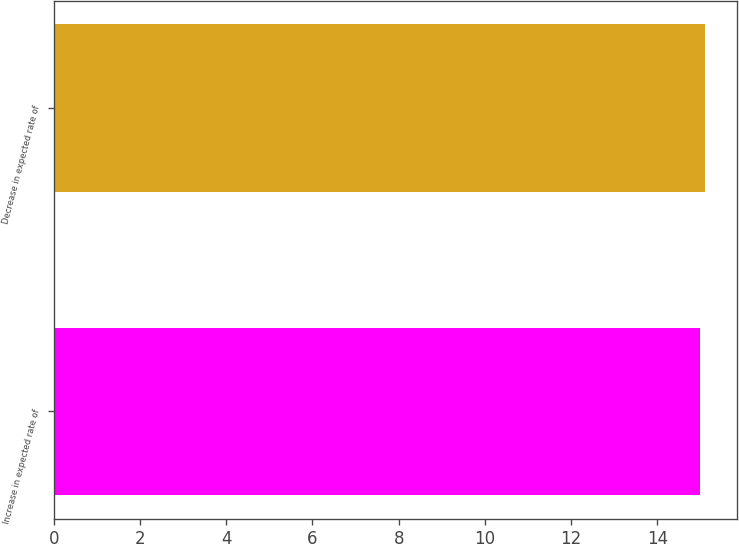Convert chart to OTSL. <chart><loc_0><loc_0><loc_500><loc_500><bar_chart><fcel>Increase in expected rate of<fcel>Decrease in expected rate of<nl><fcel>15<fcel>15.1<nl></chart> 